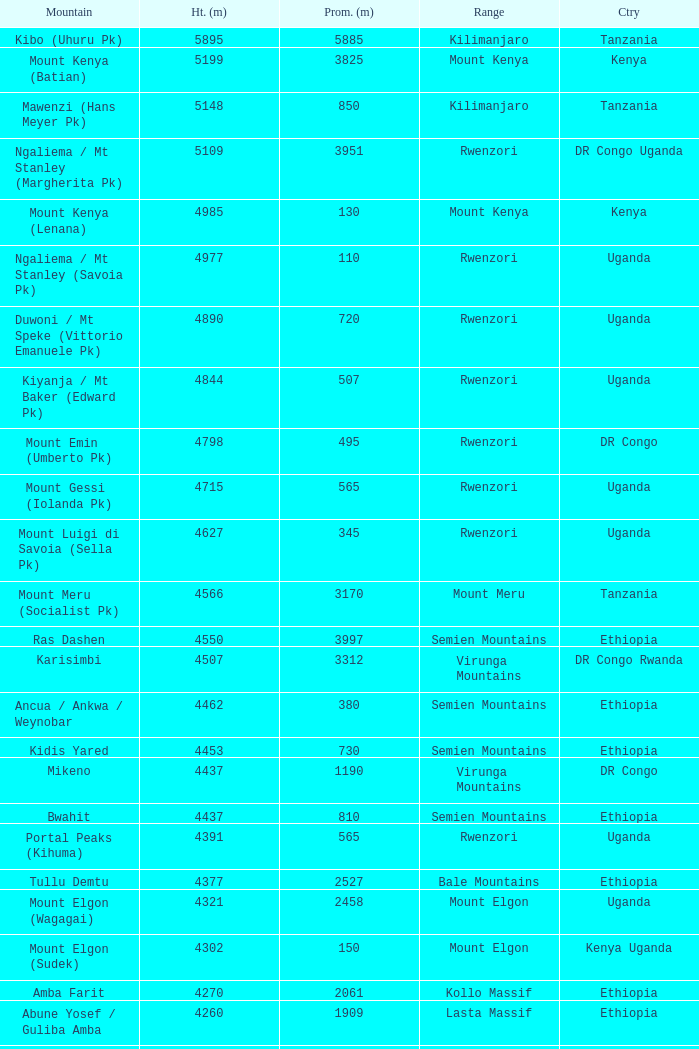Which Country has a Prominence (m) smaller than 1540, and a Height (m) smaller than 3530, and a Range of virunga mountains, and a Mountain of nyiragongo? DR Congo. 